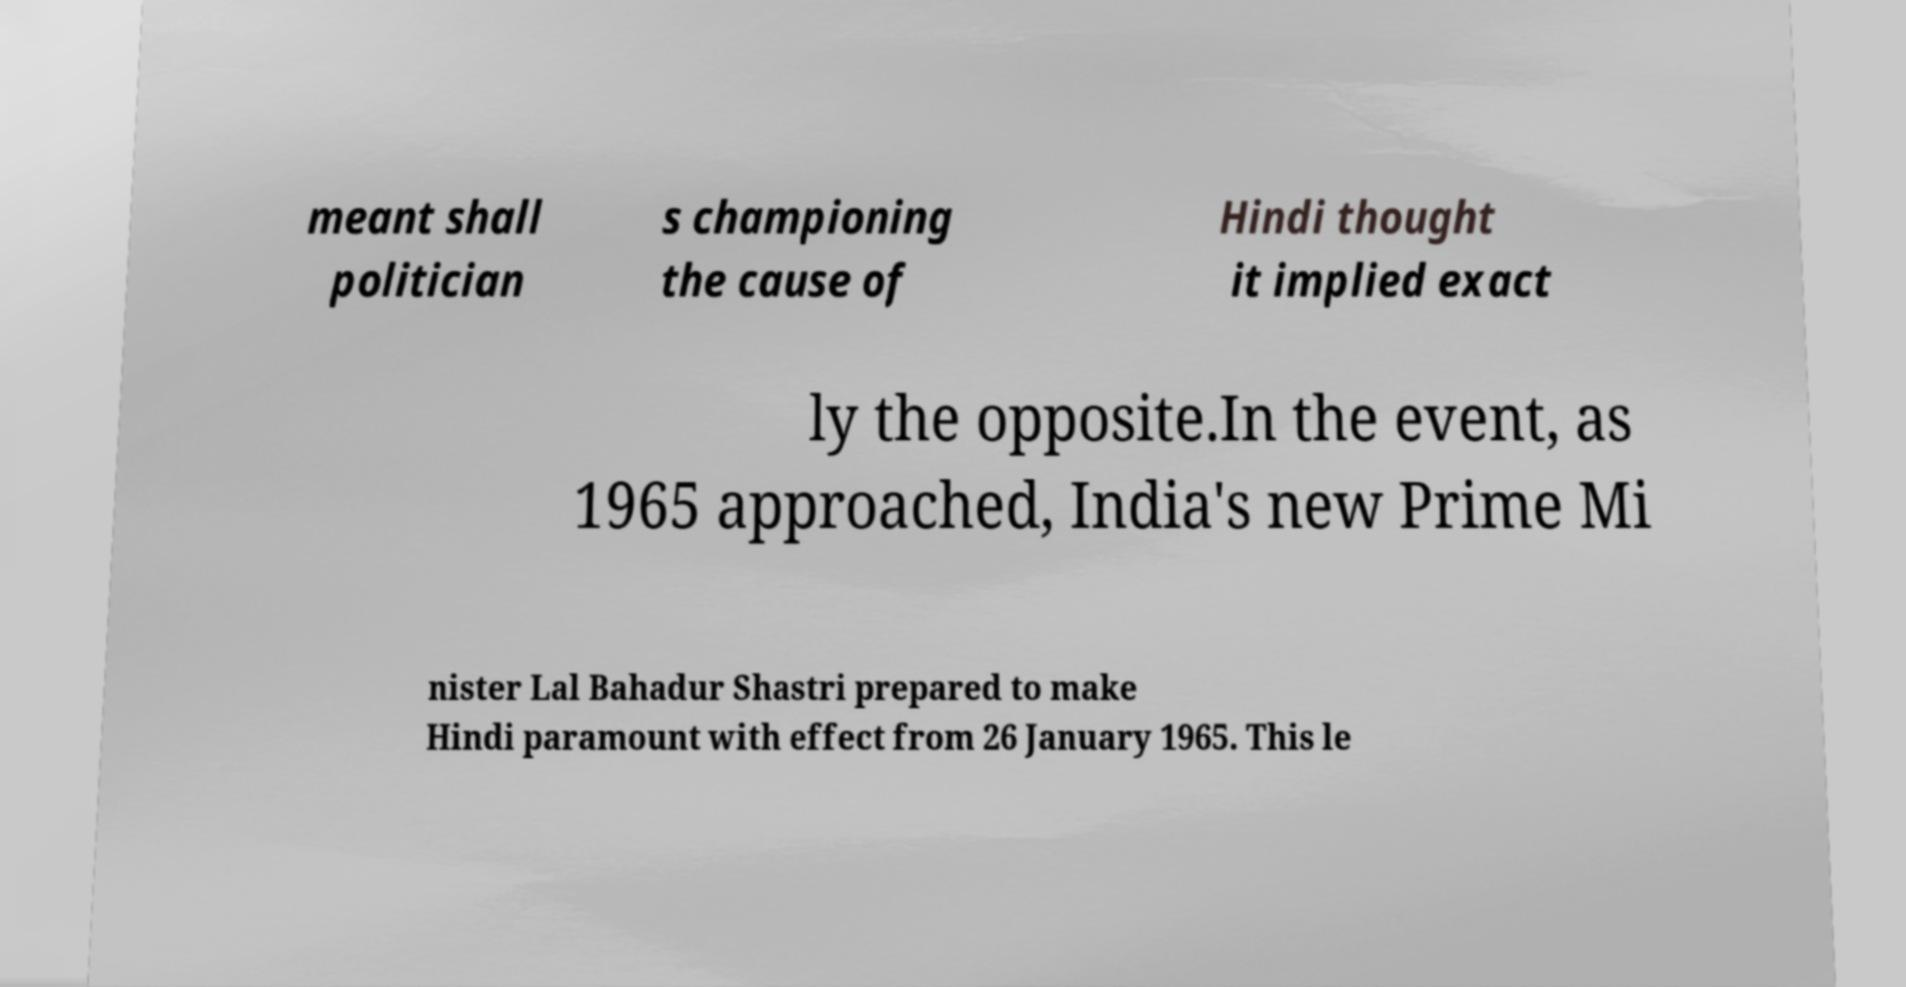Could you extract and type out the text from this image? meant shall politician s championing the cause of Hindi thought it implied exact ly the opposite.In the event, as 1965 approached, India's new Prime Mi nister Lal Bahadur Shastri prepared to make Hindi paramount with effect from 26 January 1965. This le 